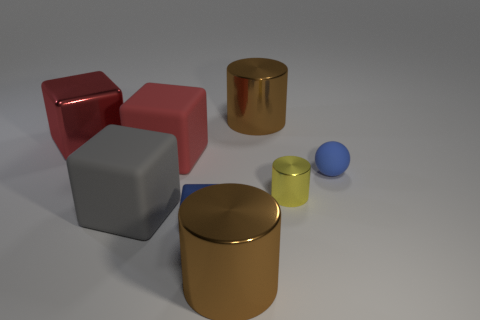There is a object that is the same color as the ball; what is its material?
Offer a terse response. Metal. There is a brown metal object in front of the blue sphere; what shape is it?
Give a very brief answer. Cylinder. There is a large gray thing that is the same shape as the red metal object; what is its material?
Your answer should be very brief. Rubber. There is a matte block that is on the left side of the red rubber block; is it the same size as the big red shiny object?
Your answer should be compact. Yes. What number of big metallic objects are in front of the gray cube?
Provide a succinct answer. 1. Is the number of small yellow cylinders that are in front of the small metallic cylinder less than the number of red blocks behind the blue block?
Your answer should be very brief. Yes. How many cyan matte spheres are there?
Your answer should be very brief. 0. What is the color of the small thing that is in front of the small metallic cylinder?
Offer a terse response. Blue. What size is the blue rubber ball?
Provide a short and direct response. Small. Is the color of the rubber sphere the same as the small metallic cube that is in front of the yellow metallic cylinder?
Provide a short and direct response. Yes. 